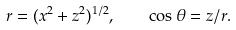<formula> <loc_0><loc_0><loc_500><loc_500>r = ( x ^ { 2 } + z ^ { 2 } ) ^ { 1 / 2 } , \quad \cos \theta = z / r .</formula> 